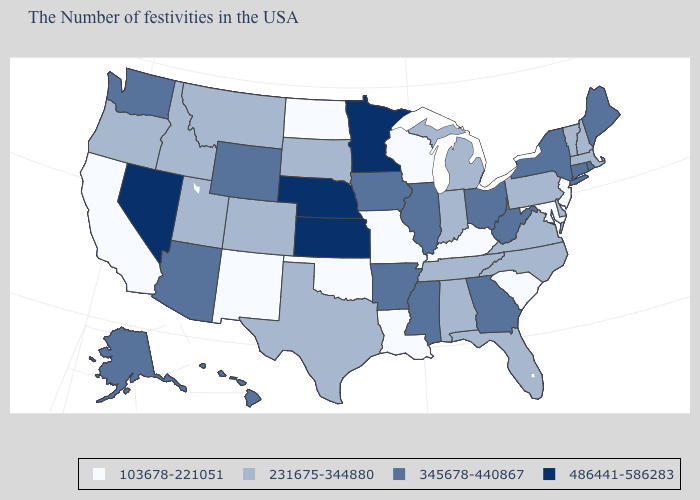Which states hav the highest value in the Northeast?
Concise answer only. Maine, Rhode Island, Connecticut, New York. Does the first symbol in the legend represent the smallest category?
Quick response, please. Yes. Which states hav the highest value in the MidWest?
Short answer required. Minnesota, Kansas, Nebraska. Among the states that border Massachusetts , which have the lowest value?
Concise answer only. New Hampshire, Vermont. What is the lowest value in states that border Georgia?
Concise answer only. 103678-221051. What is the highest value in the MidWest ?
Answer briefly. 486441-586283. Does California have the lowest value in the USA?
Quick response, please. Yes. Which states hav the highest value in the West?
Keep it brief. Nevada. Does Wyoming have a lower value than Minnesota?
Short answer required. Yes. What is the value of Oklahoma?
Be succinct. 103678-221051. What is the lowest value in the USA?
Quick response, please. 103678-221051. How many symbols are there in the legend?
Give a very brief answer. 4. Which states have the highest value in the USA?
Answer briefly. Minnesota, Kansas, Nebraska, Nevada. What is the lowest value in states that border Indiana?
Short answer required. 103678-221051. Name the states that have a value in the range 345678-440867?
Write a very short answer. Maine, Rhode Island, Connecticut, New York, West Virginia, Ohio, Georgia, Illinois, Mississippi, Arkansas, Iowa, Wyoming, Arizona, Washington, Alaska, Hawaii. 